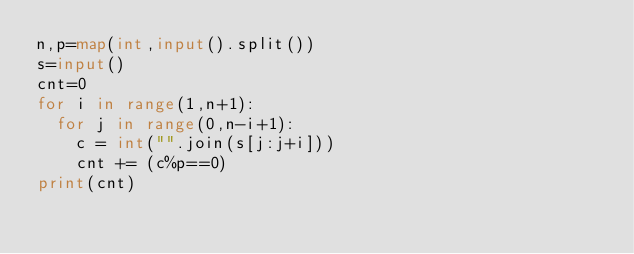Convert code to text. <code><loc_0><loc_0><loc_500><loc_500><_Python_>n,p=map(int,input().split())
s=input()
cnt=0
for i in range(1,n+1):
  for j in range(0,n-i+1):
    c = int("".join(s[j:j+i]))
    cnt += (c%p==0)
print(cnt)</code> 